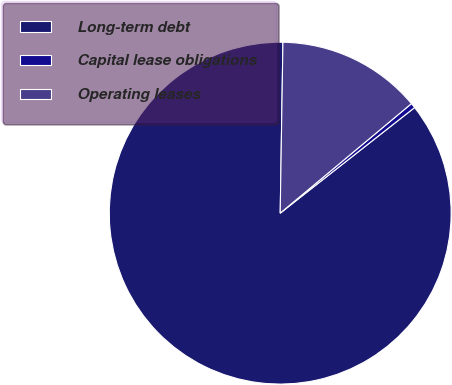Convert chart to OTSL. <chart><loc_0><loc_0><loc_500><loc_500><pie_chart><fcel>Long-term debt<fcel>Capital lease obligations<fcel>Operating leases<nl><fcel>85.86%<fcel>0.47%<fcel>13.68%<nl></chart> 